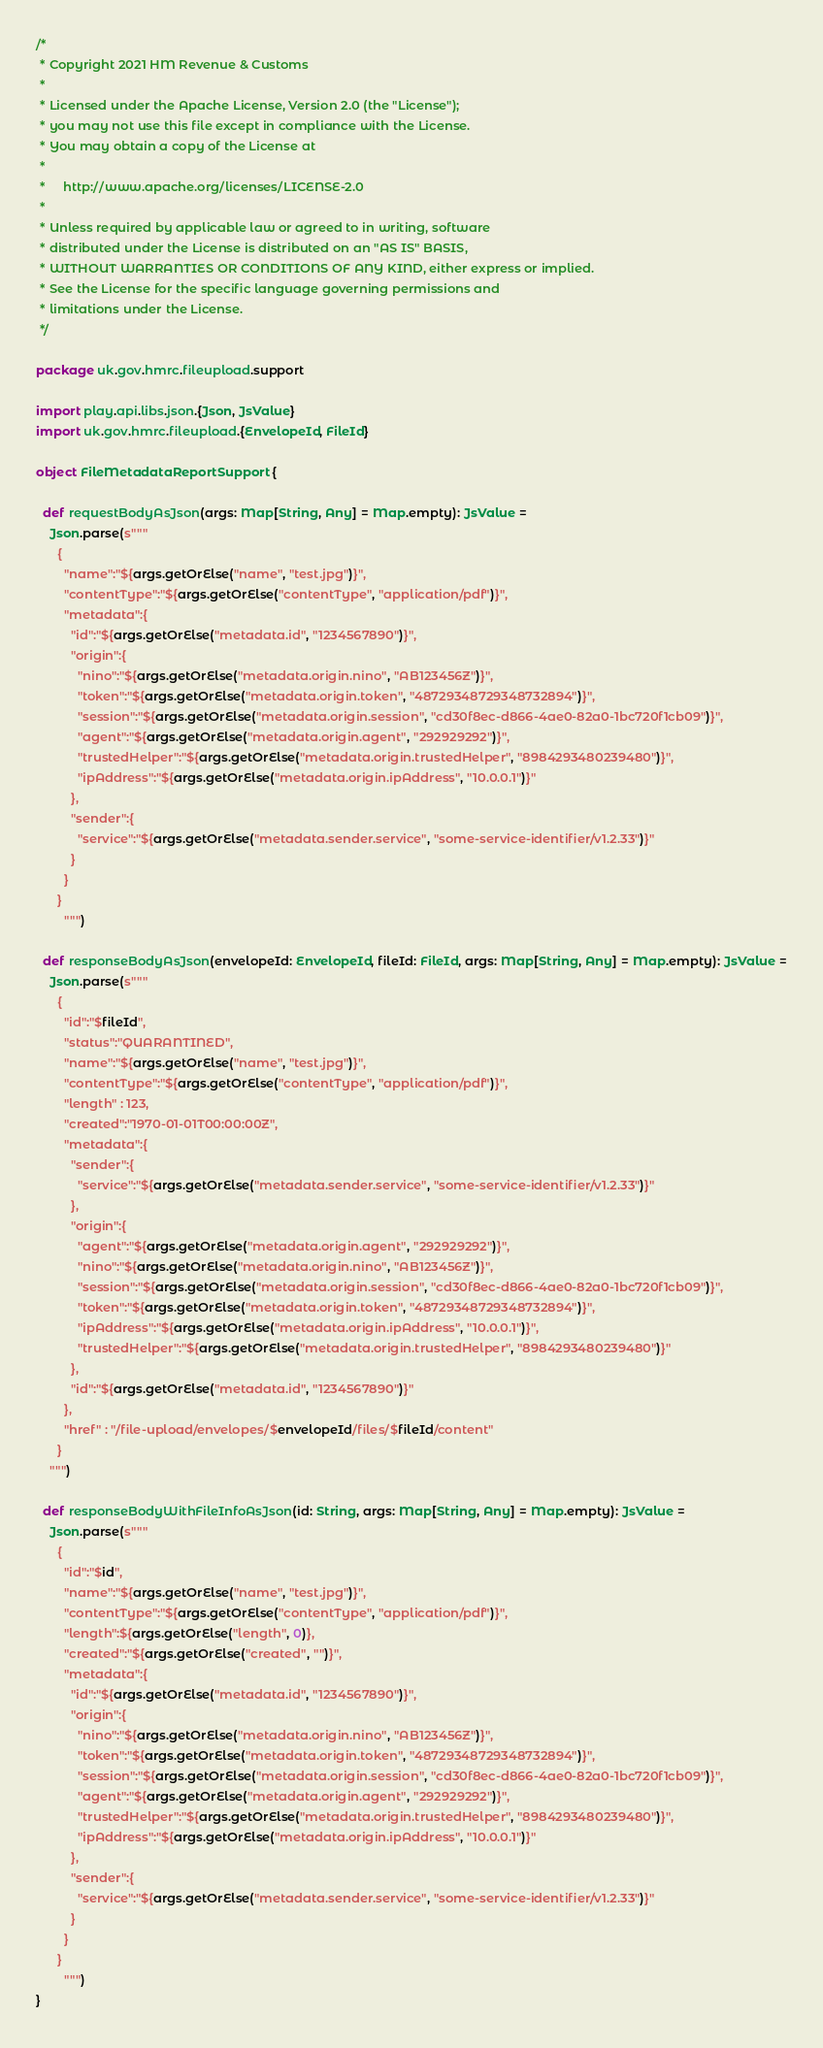<code> <loc_0><loc_0><loc_500><loc_500><_Scala_>/*
 * Copyright 2021 HM Revenue & Customs
 *
 * Licensed under the Apache License, Version 2.0 (the "License");
 * you may not use this file except in compliance with the License.
 * You may obtain a copy of the License at
 *
 *     http://www.apache.org/licenses/LICENSE-2.0
 *
 * Unless required by applicable law or agreed to in writing, software
 * distributed under the License is distributed on an "AS IS" BASIS,
 * WITHOUT WARRANTIES OR CONDITIONS OF ANY KIND, either express or implied.
 * See the License for the specific language governing permissions and
 * limitations under the License.
 */

package uk.gov.hmrc.fileupload.support

import play.api.libs.json.{Json, JsValue}
import uk.gov.hmrc.fileupload.{EnvelopeId, FileId}

object FileMetadataReportSupport {

  def requestBodyAsJson(args: Map[String, Any] = Map.empty): JsValue =
    Json.parse(s"""
      {
        "name":"${args.getOrElse("name", "test.jpg")}",
        "contentType":"${args.getOrElse("contentType", "application/pdf")}",
        "metadata":{
          "id":"${args.getOrElse("metadata.id", "1234567890")}",
          "origin":{
            "nino":"${args.getOrElse("metadata.origin.nino", "AB123456Z")}",
            "token":"${args.getOrElse("metadata.origin.token", "48729348729348732894")}",
            "session":"${args.getOrElse("metadata.origin.session", "cd30f8ec-d866-4ae0-82a0-1bc720f1cb09")}",
            "agent":"${args.getOrElse("metadata.origin.agent", "292929292")}",
            "trustedHelper":"${args.getOrElse("metadata.origin.trustedHelper", "8984293480239480")}",
            "ipAddress":"${args.getOrElse("metadata.origin.ipAddress", "10.0.0.1")}"
          },
          "sender":{
            "service":"${args.getOrElse("metadata.sender.service", "some-service-identifier/v1.2.33")}"
          }
        }
      }
		""")

  def responseBodyAsJson(envelopeId: EnvelopeId, fileId: FileId, args: Map[String, Any] = Map.empty): JsValue =
    Json.parse(s"""
      {
        "id":"$fileId",
        "status":"QUARANTINED",
        "name":"${args.getOrElse("name", "test.jpg")}",
        "contentType":"${args.getOrElse("contentType", "application/pdf")}",
        "length" : 123,
        "created":"1970-01-01T00:00:00Z",
        "metadata":{
          "sender":{
            "service":"${args.getOrElse("metadata.sender.service", "some-service-identifier/v1.2.33")}"
          },
          "origin":{
            "agent":"${args.getOrElse("metadata.origin.agent", "292929292")}",
            "nino":"${args.getOrElse("metadata.origin.nino", "AB123456Z")}",
            "session":"${args.getOrElse("metadata.origin.session", "cd30f8ec-d866-4ae0-82a0-1bc720f1cb09")}",
            "token":"${args.getOrElse("metadata.origin.token", "48729348729348732894")}",
            "ipAddress":"${args.getOrElse("metadata.origin.ipAddress", "10.0.0.1")}",
            "trustedHelper":"${args.getOrElse("metadata.origin.trustedHelper", "8984293480239480")}"
          },
          "id":"${args.getOrElse("metadata.id", "1234567890")}"
        },
        "href" : "/file-upload/envelopes/$envelopeId/files/$fileId/content"
      }
    """)

  def responseBodyWithFileInfoAsJson(id: String, args: Map[String, Any] = Map.empty): JsValue =
    Json.parse(s"""
      {
        "id":"$id",
        "name":"${args.getOrElse("name", "test.jpg")}",
        "contentType":"${args.getOrElse("contentType", "application/pdf")}",
        "length":${args.getOrElse("length", 0)},
        "created":"${args.getOrElse("created", "")}",
        "metadata":{
          "id":"${args.getOrElse("metadata.id", "1234567890")}",
          "origin":{
            "nino":"${args.getOrElse("metadata.origin.nino", "AB123456Z")}",
            "token":"${args.getOrElse("metadata.origin.token", "48729348729348732894")}",
            "session":"${args.getOrElse("metadata.origin.session", "cd30f8ec-d866-4ae0-82a0-1bc720f1cb09")}",
            "agent":"${args.getOrElse("metadata.origin.agent", "292929292")}",
            "trustedHelper":"${args.getOrElse("metadata.origin.trustedHelper", "8984293480239480")}",
            "ipAddress":"${args.getOrElse("metadata.origin.ipAddress", "10.0.0.1")}"
          },
          "sender":{
            "service":"${args.getOrElse("metadata.sender.service", "some-service-identifier/v1.2.33")}"
          }
        }
      }
		""")
}
</code> 